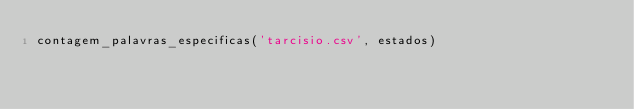<code> <loc_0><loc_0><loc_500><loc_500><_Python_>contagem_palavras_especificas('tarcisio.csv', estados)</code> 